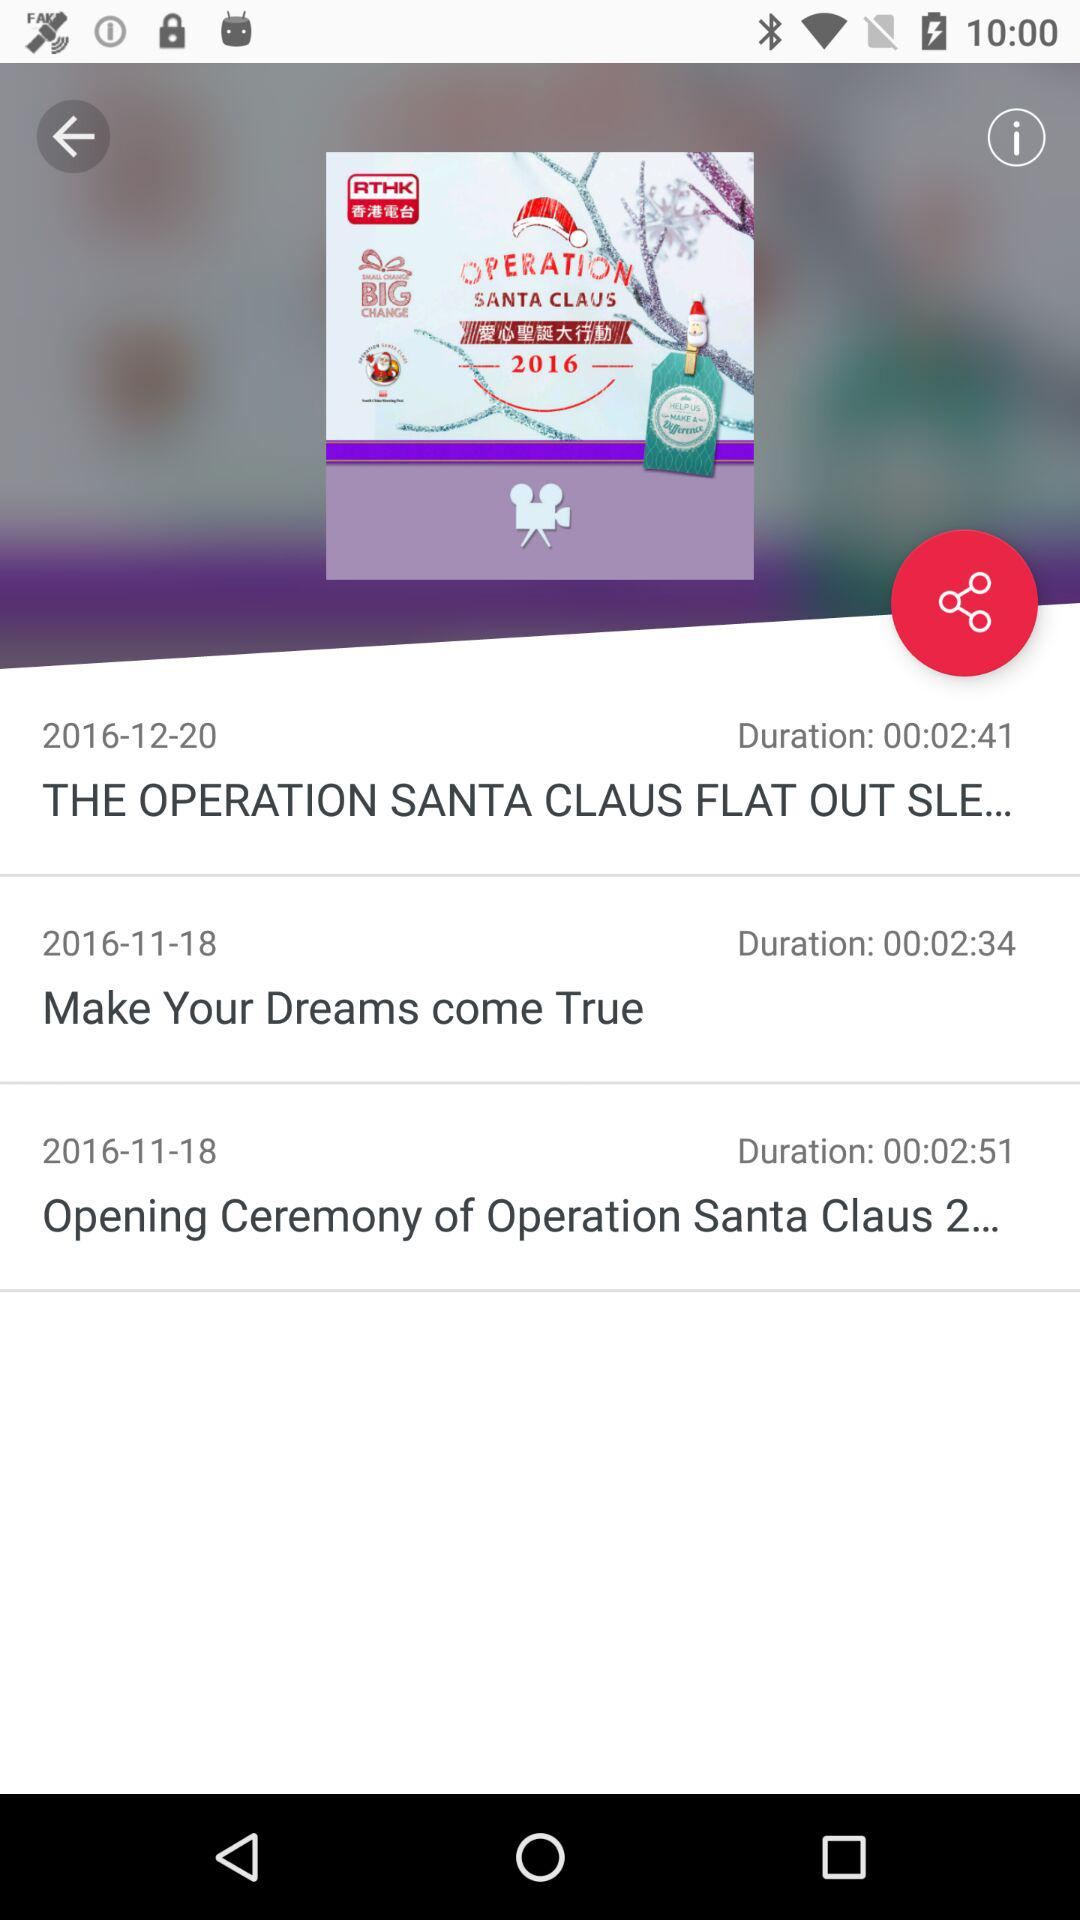What is the duration of "Make Your Dreams come True"? The duration is 00:02:34. 